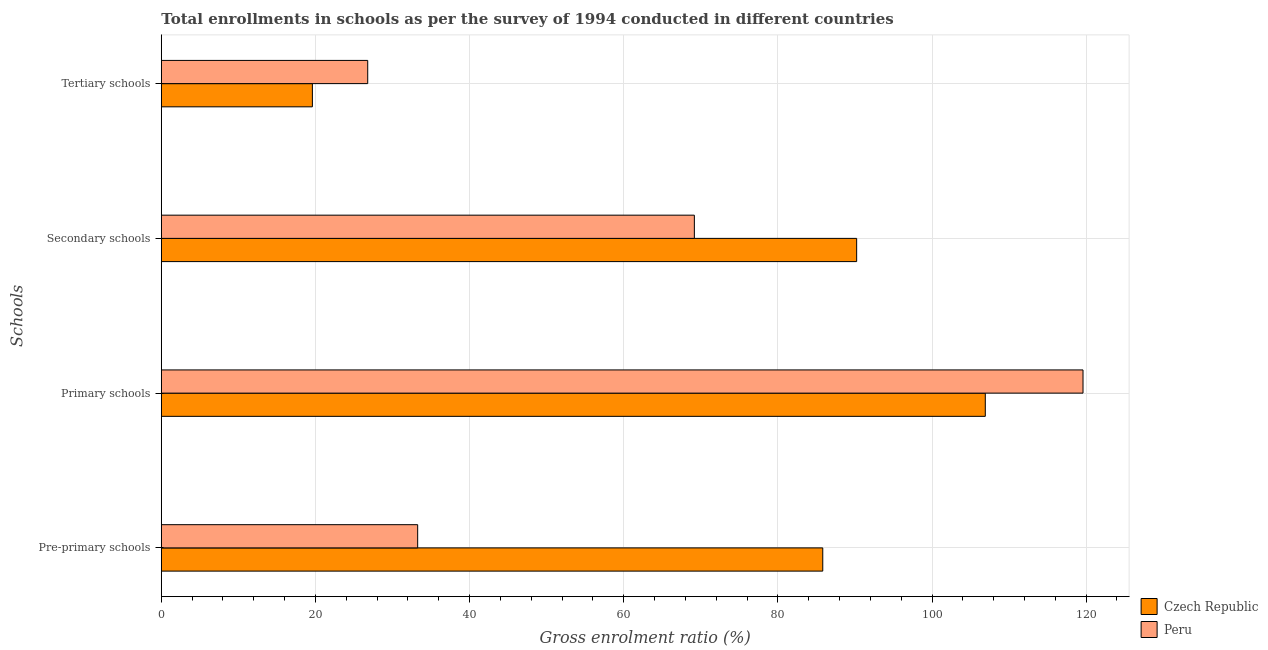Are the number of bars per tick equal to the number of legend labels?
Ensure brevity in your answer.  Yes. Are the number of bars on each tick of the Y-axis equal?
Give a very brief answer. Yes. What is the label of the 2nd group of bars from the top?
Provide a succinct answer. Secondary schools. What is the gross enrolment ratio in tertiary schools in Czech Republic?
Provide a succinct answer. 19.6. Across all countries, what is the maximum gross enrolment ratio in pre-primary schools?
Keep it short and to the point. 85.82. Across all countries, what is the minimum gross enrolment ratio in secondary schools?
Make the answer very short. 69.16. What is the total gross enrolment ratio in primary schools in the graph?
Offer a very short reply. 226.51. What is the difference between the gross enrolment ratio in primary schools in Peru and that in Czech Republic?
Your answer should be very brief. 12.68. What is the difference between the gross enrolment ratio in primary schools in Czech Republic and the gross enrolment ratio in pre-primary schools in Peru?
Offer a terse response. 73.65. What is the average gross enrolment ratio in pre-primary schools per country?
Offer a terse response. 59.54. What is the difference between the gross enrolment ratio in tertiary schools and gross enrolment ratio in secondary schools in Czech Republic?
Ensure brevity in your answer.  -70.62. In how many countries, is the gross enrolment ratio in primary schools greater than 36 %?
Ensure brevity in your answer.  2. What is the ratio of the gross enrolment ratio in tertiary schools in Czech Republic to that in Peru?
Your answer should be compact. 0.73. Is the difference between the gross enrolment ratio in tertiary schools in Peru and Czech Republic greater than the difference between the gross enrolment ratio in pre-primary schools in Peru and Czech Republic?
Offer a very short reply. Yes. What is the difference between the highest and the second highest gross enrolment ratio in primary schools?
Ensure brevity in your answer.  12.68. What is the difference between the highest and the lowest gross enrolment ratio in primary schools?
Provide a succinct answer. 12.68. Is the sum of the gross enrolment ratio in secondary schools in Peru and Czech Republic greater than the maximum gross enrolment ratio in primary schools across all countries?
Your response must be concise. Yes. Is it the case that in every country, the sum of the gross enrolment ratio in secondary schools and gross enrolment ratio in tertiary schools is greater than the sum of gross enrolment ratio in primary schools and gross enrolment ratio in pre-primary schools?
Make the answer very short. No. What does the 2nd bar from the top in Pre-primary schools represents?
Provide a succinct answer. Czech Republic. What does the 2nd bar from the bottom in Tertiary schools represents?
Your answer should be very brief. Peru. Is it the case that in every country, the sum of the gross enrolment ratio in pre-primary schools and gross enrolment ratio in primary schools is greater than the gross enrolment ratio in secondary schools?
Offer a terse response. Yes. How many bars are there?
Offer a terse response. 8. Are all the bars in the graph horizontal?
Keep it short and to the point. Yes. How many legend labels are there?
Offer a terse response. 2. How are the legend labels stacked?
Your answer should be compact. Vertical. What is the title of the graph?
Make the answer very short. Total enrollments in schools as per the survey of 1994 conducted in different countries. Does "Cote d'Ivoire" appear as one of the legend labels in the graph?
Your answer should be compact. No. What is the label or title of the X-axis?
Provide a succinct answer. Gross enrolment ratio (%). What is the label or title of the Y-axis?
Your response must be concise. Schools. What is the Gross enrolment ratio (%) of Czech Republic in Pre-primary schools?
Provide a short and direct response. 85.82. What is the Gross enrolment ratio (%) in Peru in Pre-primary schools?
Give a very brief answer. 33.26. What is the Gross enrolment ratio (%) in Czech Republic in Primary schools?
Give a very brief answer. 106.91. What is the Gross enrolment ratio (%) of Peru in Primary schools?
Your answer should be very brief. 119.59. What is the Gross enrolment ratio (%) of Czech Republic in Secondary schools?
Ensure brevity in your answer.  90.22. What is the Gross enrolment ratio (%) in Peru in Secondary schools?
Keep it short and to the point. 69.16. What is the Gross enrolment ratio (%) in Czech Republic in Tertiary schools?
Give a very brief answer. 19.6. What is the Gross enrolment ratio (%) of Peru in Tertiary schools?
Ensure brevity in your answer.  26.78. Across all Schools, what is the maximum Gross enrolment ratio (%) of Czech Republic?
Make the answer very short. 106.91. Across all Schools, what is the maximum Gross enrolment ratio (%) of Peru?
Keep it short and to the point. 119.59. Across all Schools, what is the minimum Gross enrolment ratio (%) in Czech Republic?
Your response must be concise. 19.6. Across all Schools, what is the minimum Gross enrolment ratio (%) of Peru?
Your answer should be compact. 26.78. What is the total Gross enrolment ratio (%) in Czech Republic in the graph?
Your answer should be very brief. 302.56. What is the total Gross enrolment ratio (%) in Peru in the graph?
Offer a terse response. 248.8. What is the difference between the Gross enrolment ratio (%) in Czech Republic in Pre-primary schools and that in Primary schools?
Your answer should be compact. -21.09. What is the difference between the Gross enrolment ratio (%) in Peru in Pre-primary schools and that in Primary schools?
Provide a succinct answer. -86.33. What is the difference between the Gross enrolment ratio (%) of Czech Republic in Pre-primary schools and that in Secondary schools?
Provide a short and direct response. -4.4. What is the difference between the Gross enrolment ratio (%) in Peru in Pre-primary schools and that in Secondary schools?
Your answer should be compact. -35.9. What is the difference between the Gross enrolment ratio (%) of Czech Republic in Pre-primary schools and that in Tertiary schools?
Give a very brief answer. 66.22. What is the difference between the Gross enrolment ratio (%) in Peru in Pre-primary schools and that in Tertiary schools?
Your answer should be compact. 6.48. What is the difference between the Gross enrolment ratio (%) of Czech Republic in Primary schools and that in Secondary schools?
Make the answer very short. 16.69. What is the difference between the Gross enrolment ratio (%) in Peru in Primary schools and that in Secondary schools?
Give a very brief answer. 50.43. What is the difference between the Gross enrolment ratio (%) of Czech Republic in Primary schools and that in Tertiary schools?
Make the answer very short. 87.31. What is the difference between the Gross enrolment ratio (%) in Peru in Primary schools and that in Tertiary schools?
Provide a short and direct response. 92.81. What is the difference between the Gross enrolment ratio (%) in Czech Republic in Secondary schools and that in Tertiary schools?
Offer a very short reply. 70.62. What is the difference between the Gross enrolment ratio (%) in Peru in Secondary schools and that in Tertiary schools?
Keep it short and to the point. 42.38. What is the difference between the Gross enrolment ratio (%) in Czech Republic in Pre-primary schools and the Gross enrolment ratio (%) in Peru in Primary schools?
Ensure brevity in your answer.  -33.77. What is the difference between the Gross enrolment ratio (%) of Czech Republic in Pre-primary schools and the Gross enrolment ratio (%) of Peru in Secondary schools?
Your answer should be very brief. 16.66. What is the difference between the Gross enrolment ratio (%) of Czech Republic in Pre-primary schools and the Gross enrolment ratio (%) of Peru in Tertiary schools?
Offer a very short reply. 59.04. What is the difference between the Gross enrolment ratio (%) of Czech Republic in Primary schools and the Gross enrolment ratio (%) of Peru in Secondary schools?
Your answer should be very brief. 37.75. What is the difference between the Gross enrolment ratio (%) of Czech Republic in Primary schools and the Gross enrolment ratio (%) of Peru in Tertiary schools?
Give a very brief answer. 80.13. What is the difference between the Gross enrolment ratio (%) in Czech Republic in Secondary schools and the Gross enrolment ratio (%) in Peru in Tertiary schools?
Give a very brief answer. 63.44. What is the average Gross enrolment ratio (%) of Czech Republic per Schools?
Your answer should be very brief. 75.64. What is the average Gross enrolment ratio (%) in Peru per Schools?
Offer a very short reply. 62.2. What is the difference between the Gross enrolment ratio (%) in Czech Republic and Gross enrolment ratio (%) in Peru in Pre-primary schools?
Provide a short and direct response. 52.56. What is the difference between the Gross enrolment ratio (%) in Czech Republic and Gross enrolment ratio (%) in Peru in Primary schools?
Your answer should be very brief. -12.68. What is the difference between the Gross enrolment ratio (%) of Czech Republic and Gross enrolment ratio (%) of Peru in Secondary schools?
Your answer should be compact. 21.06. What is the difference between the Gross enrolment ratio (%) of Czech Republic and Gross enrolment ratio (%) of Peru in Tertiary schools?
Provide a succinct answer. -7.18. What is the ratio of the Gross enrolment ratio (%) of Czech Republic in Pre-primary schools to that in Primary schools?
Provide a succinct answer. 0.8. What is the ratio of the Gross enrolment ratio (%) of Peru in Pre-primary schools to that in Primary schools?
Keep it short and to the point. 0.28. What is the ratio of the Gross enrolment ratio (%) in Czech Republic in Pre-primary schools to that in Secondary schools?
Your answer should be very brief. 0.95. What is the ratio of the Gross enrolment ratio (%) of Peru in Pre-primary schools to that in Secondary schools?
Your response must be concise. 0.48. What is the ratio of the Gross enrolment ratio (%) in Czech Republic in Pre-primary schools to that in Tertiary schools?
Keep it short and to the point. 4.38. What is the ratio of the Gross enrolment ratio (%) of Peru in Pre-primary schools to that in Tertiary schools?
Make the answer very short. 1.24. What is the ratio of the Gross enrolment ratio (%) in Czech Republic in Primary schools to that in Secondary schools?
Make the answer very short. 1.19. What is the ratio of the Gross enrolment ratio (%) of Peru in Primary schools to that in Secondary schools?
Your response must be concise. 1.73. What is the ratio of the Gross enrolment ratio (%) of Czech Republic in Primary schools to that in Tertiary schools?
Provide a succinct answer. 5.45. What is the ratio of the Gross enrolment ratio (%) in Peru in Primary schools to that in Tertiary schools?
Give a very brief answer. 4.47. What is the ratio of the Gross enrolment ratio (%) of Czech Republic in Secondary schools to that in Tertiary schools?
Give a very brief answer. 4.6. What is the ratio of the Gross enrolment ratio (%) in Peru in Secondary schools to that in Tertiary schools?
Your answer should be compact. 2.58. What is the difference between the highest and the second highest Gross enrolment ratio (%) in Czech Republic?
Your response must be concise. 16.69. What is the difference between the highest and the second highest Gross enrolment ratio (%) of Peru?
Provide a short and direct response. 50.43. What is the difference between the highest and the lowest Gross enrolment ratio (%) in Czech Republic?
Offer a very short reply. 87.31. What is the difference between the highest and the lowest Gross enrolment ratio (%) in Peru?
Make the answer very short. 92.81. 